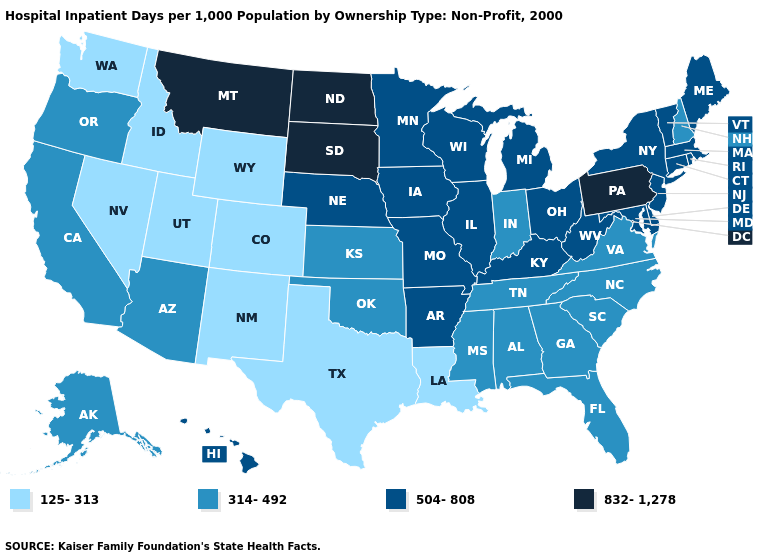Does the first symbol in the legend represent the smallest category?
Short answer required. Yes. What is the value of Hawaii?
Keep it brief. 504-808. Name the states that have a value in the range 314-492?
Short answer required. Alabama, Alaska, Arizona, California, Florida, Georgia, Indiana, Kansas, Mississippi, New Hampshire, North Carolina, Oklahoma, Oregon, South Carolina, Tennessee, Virginia. Name the states that have a value in the range 832-1,278?
Give a very brief answer. Montana, North Dakota, Pennsylvania, South Dakota. Name the states that have a value in the range 314-492?
Concise answer only. Alabama, Alaska, Arizona, California, Florida, Georgia, Indiana, Kansas, Mississippi, New Hampshire, North Carolina, Oklahoma, Oregon, South Carolina, Tennessee, Virginia. What is the value of Hawaii?
Give a very brief answer. 504-808. Does North Dakota have the highest value in the USA?
Be succinct. Yes. What is the highest value in the Northeast ?
Answer briefly. 832-1,278. Which states have the highest value in the USA?
Give a very brief answer. Montana, North Dakota, Pennsylvania, South Dakota. Name the states that have a value in the range 314-492?
Short answer required. Alabama, Alaska, Arizona, California, Florida, Georgia, Indiana, Kansas, Mississippi, New Hampshire, North Carolina, Oklahoma, Oregon, South Carolina, Tennessee, Virginia. What is the lowest value in the USA?
Quick response, please. 125-313. Does California have the lowest value in the USA?
Quick response, please. No. Name the states that have a value in the range 125-313?
Concise answer only. Colorado, Idaho, Louisiana, Nevada, New Mexico, Texas, Utah, Washington, Wyoming. Name the states that have a value in the range 125-313?
Answer briefly. Colorado, Idaho, Louisiana, Nevada, New Mexico, Texas, Utah, Washington, Wyoming. Does New Mexico have the lowest value in the USA?
Quick response, please. Yes. 